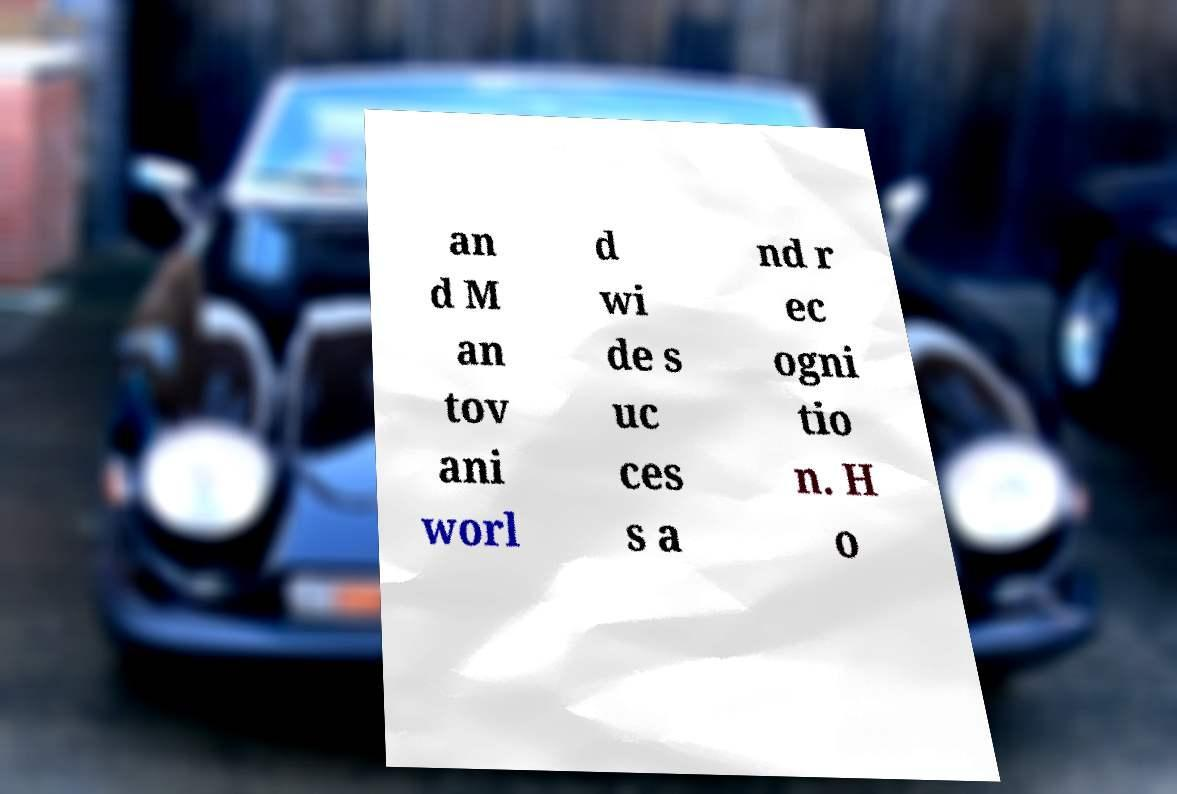Please read and relay the text visible in this image. What does it say? an d M an tov ani worl d wi de s uc ces s a nd r ec ogni tio n. H o 